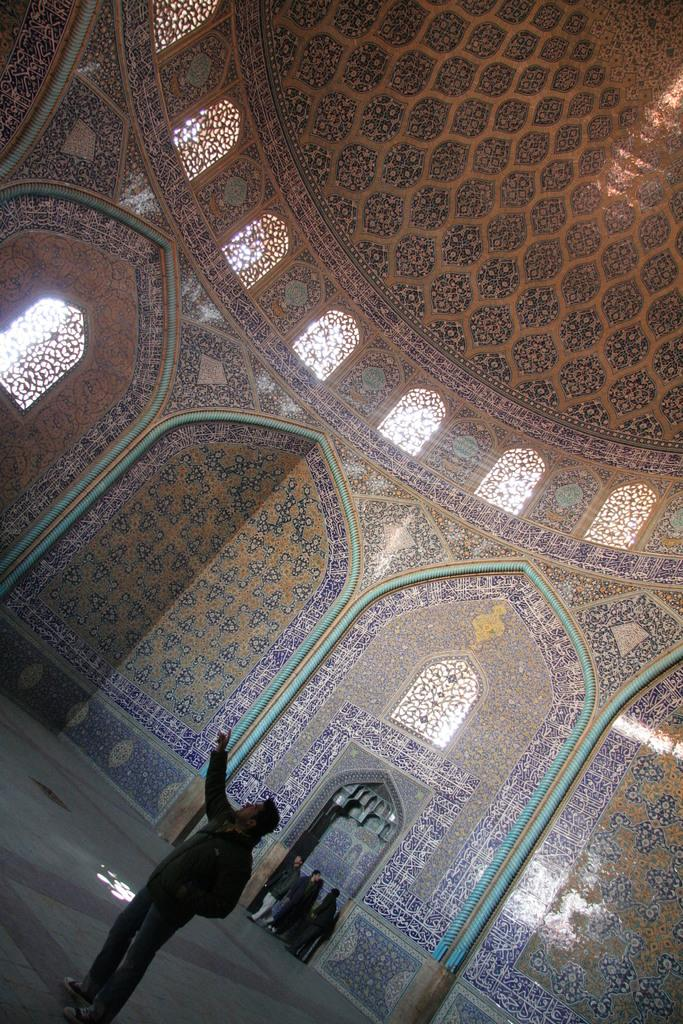Who or what can be seen in the image? There are people in the image. What is visible in the background of the image? There is a wall with a visible texture and windows in the background of the image. What type of dirt can be seen on the board in the image? There is no board or dirt present in the image. 